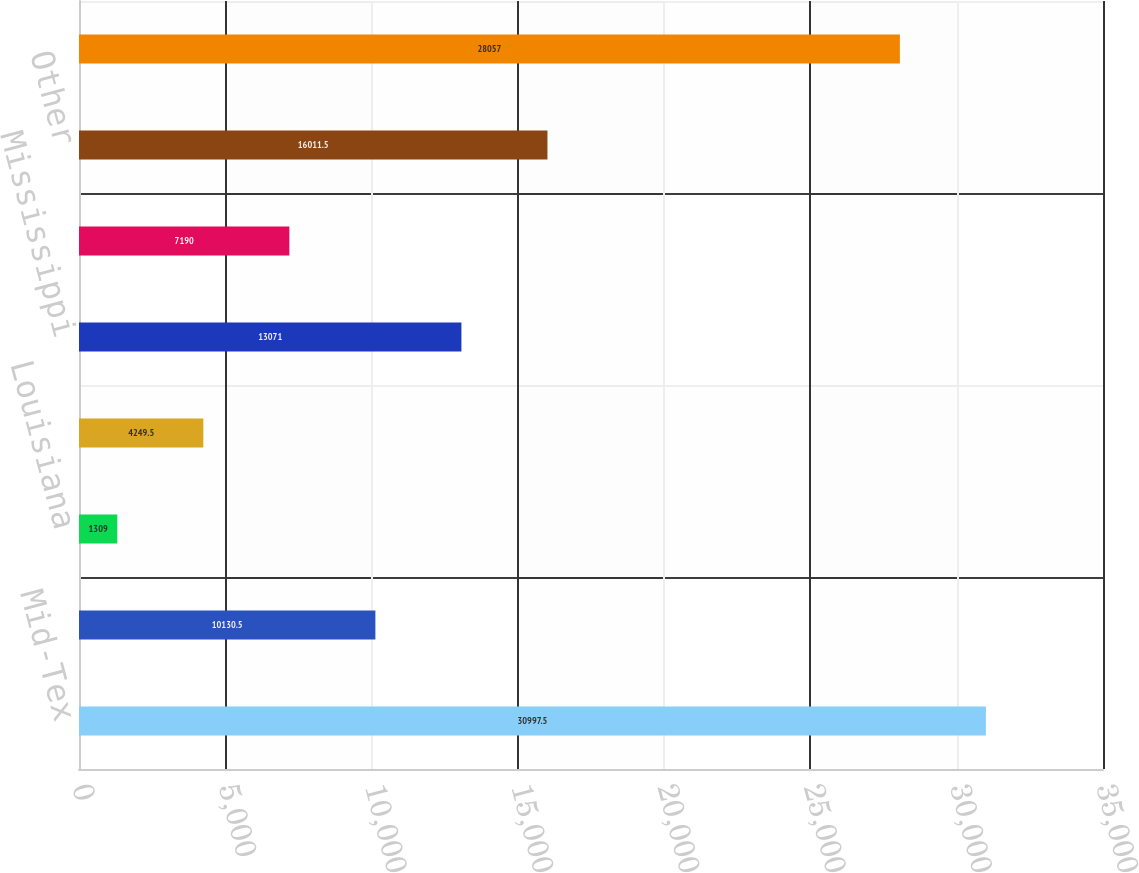<chart> <loc_0><loc_0><loc_500><loc_500><bar_chart><fcel>Mid-Tex<fcel>Kentucky/Mid-States<fcel>Louisiana<fcel>West Texas<fcel>Mississippi<fcel>Colorado-Kansas<fcel>Other<fcel>Total<nl><fcel>30997.5<fcel>10130.5<fcel>1309<fcel>4249.5<fcel>13071<fcel>7190<fcel>16011.5<fcel>28057<nl></chart> 